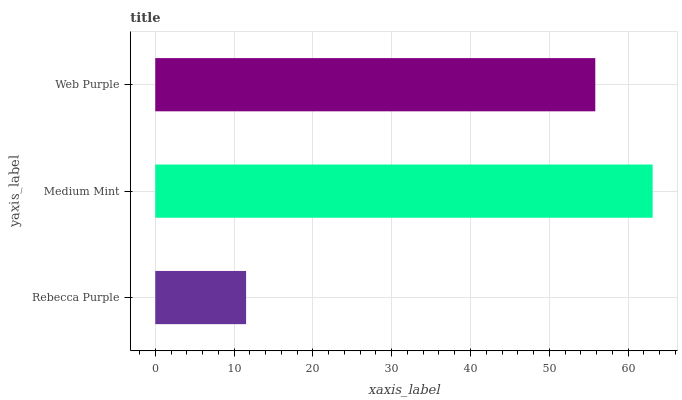Is Rebecca Purple the minimum?
Answer yes or no. Yes. Is Medium Mint the maximum?
Answer yes or no. Yes. Is Web Purple the minimum?
Answer yes or no. No. Is Web Purple the maximum?
Answer yes or no. No. Is Medium Mint greater than Web Purple?
Answer yes or no. Yes. Is Web Purple less than Medium Mint?
Answer yes or no. Yes. Is Web Purple greater than Medium Mint?
Answer yes or no. No. Is Medium Mint less than Web Purple?
Answer yes or no. No. Is Web Purple the high median?
Answer yes or no. Yes. Is Web Purple the low median?
Answer yes or no. Yes. Is Rebecca Purple the high median?
Answer yes or no. No. Is Rebecca Purple the low median?
Answer yes or no. No. 